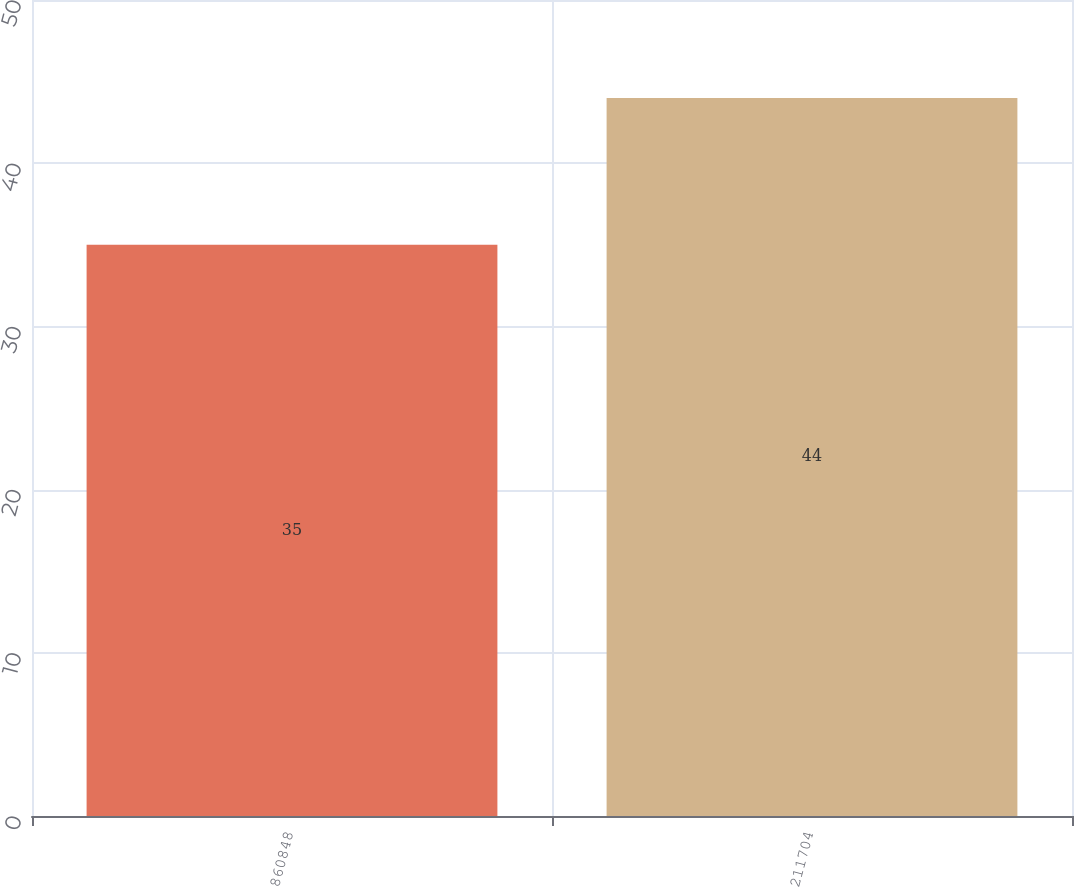Convert chart to OTSL. <chart><loc_0><loc_0><loc_500><loc_500><bar_chart><fcel>860848<fcel>211704<nl><fcel>35<fcel>44<nl></chart> 